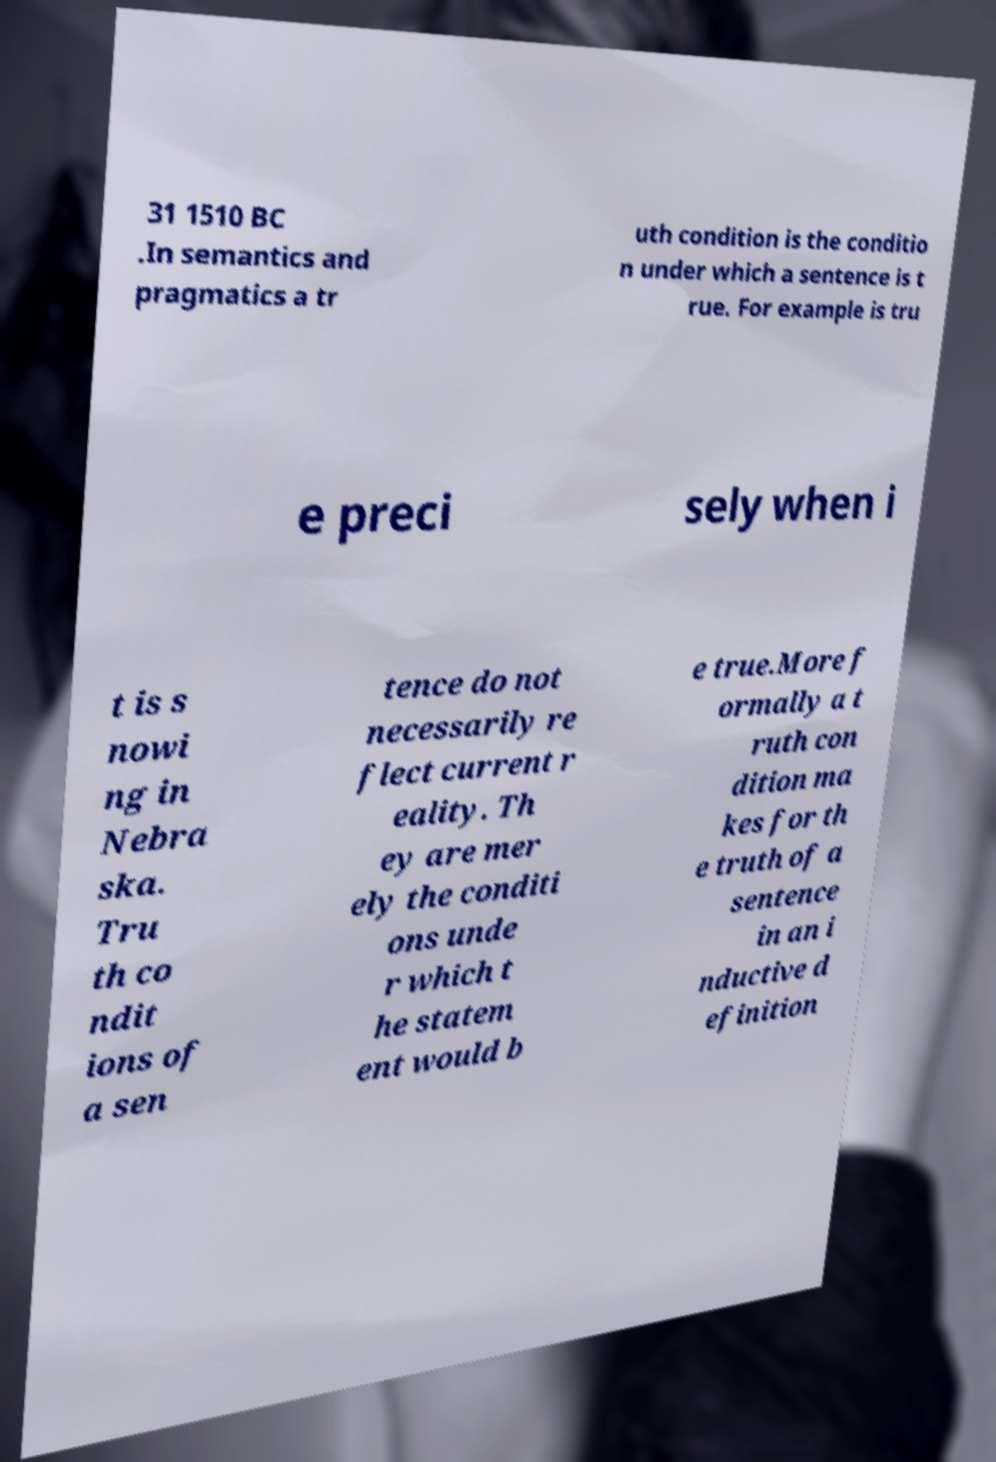Can you read and provide the text displayed in the image?This photo seems to have some interesting text. Can you extract and type it out for me? 31 1510 BC .In semantics and pragmatics a tr uth condition is the conditio n under which a sentence is t rue. For example is tru e preci sely when i t is s nowi ng in Nebra ska. Tru th co ndit ions of a sen tence do not necessarily re flect current r eality. Th ey are mer ely the conditi ons unde r which t he statem ent would b e true.More f ormally a t ruth con dition ma kes for th e truth of a sentence in an i nductive d efinition 